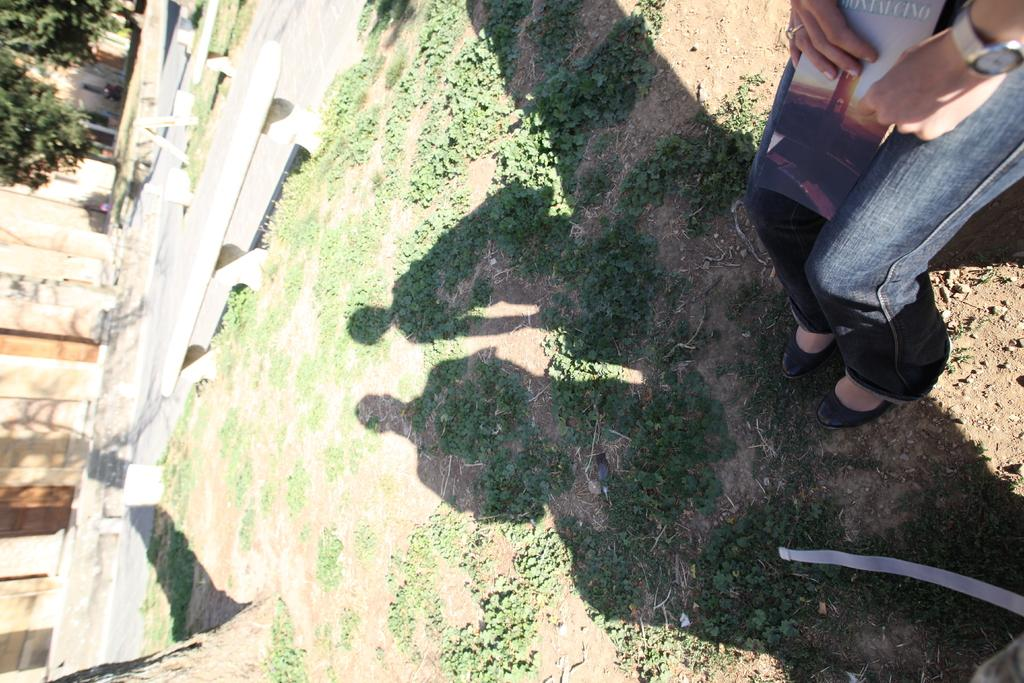What can be seen on the ground in the image? There are shadows of two persons on the ground. What is the person holding in the image? The person is holding a book. What can be seen in the background of the image? There are trees, benches, and a wall in the background. In which direction are the persons facing in the image? The image does not provide information about the direction the persons are facing. What type of fuel is being used by the airplane in the image? There is no airplane present in the image. 